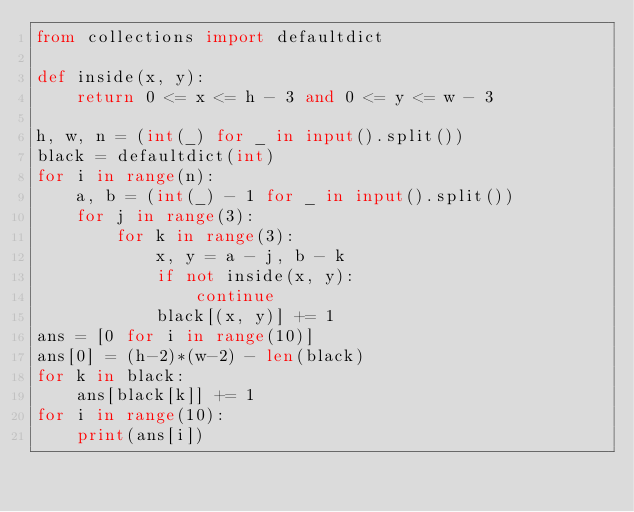<code> <loc_0><loc_0><loc_500><loc_500><_Python_>from collections import defaultdict

def inside(x, y):    
    return 0 <= x <= h - 3 and 0 <= y <= w - 3

h, w, n = (int(_) for _ in input().split())
black = defaultdict(int)
for i in range(n):
    a, b = (int(_) - 1 for _ in input().split())
    for j in range(3):
        for k in range(3):
            x, y = a - j, b - k
            if not inside(x, y):
                continue
            black[(x, y)] += 1
ans = [0 for i in range(10)]
ans[0] = (h-2)*(w-2) - len(black)
for k in black:
    ans[black[k]] += 1
for i in range(10):
    print(ans[i])
</code> 